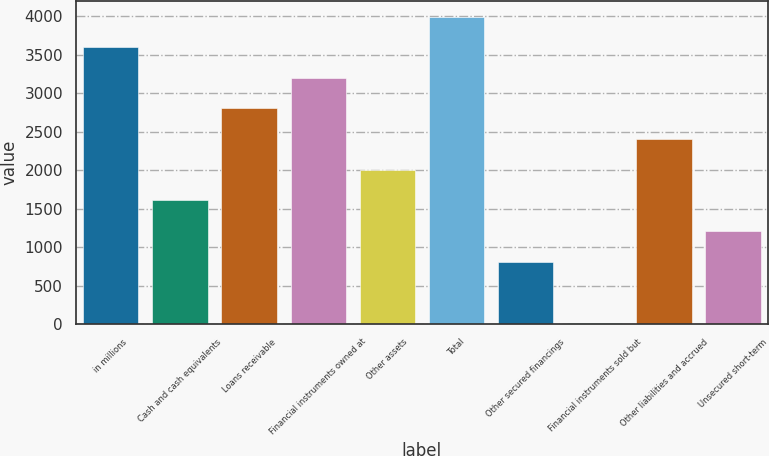Convert chart. <chart><loc_0><loc_0><loc_500><loc_500><bar_chart><fcel>in millions<fcel>Cash and cash equivalents<fcel>Loans receivable<fcel>Financial instruments owned at<fcel>Other assets<fcel>Total<fcel>Other secured financings<fcel>Financial instruments sold but<fcel>Other liabilities and accrued<fcel>Unsecured short-term<nl><fcel>3600.7<fcel>1609.2<fcel>2804.1<fcel>3202.4<fcel>2007.5<fcel>3999<fcel>812.6<fcel>16<fcel>2405.8<fcel>1210.9<nl></chart> 